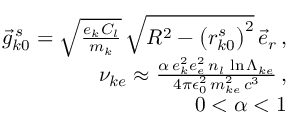Convert formula to latex. <formula><loc_0><loc_0><loc_500><loc_500>\begin{array} { r l r } & { \vec { g } _ { k 0 } ^ { \, s } = \sqrt { \frac { e _ { k } C _ { l } } { m _ { k } } } \, \sqrt { R ^ { 2 } - \left ( r _ { k 0 } ^ { s } \right ) ^ { 2 } } \, \vec { e } _ { r } \, , } \\ & { \nu _ { k e } \approx \frac { \alpha \, e _ { k } ^ { 2 } e _ { e } ^ { 2 } \, n _ { l } \, \ln \Lambda _ { k e } } { 4 \pi \epsilon _ { 0 } ^ { 2 } \, m _ { k e } ^ { 2 } \, c ^ { 3 } } \, , } \\ & { 0 < \alpha < 1 } \end{array}</formula> 